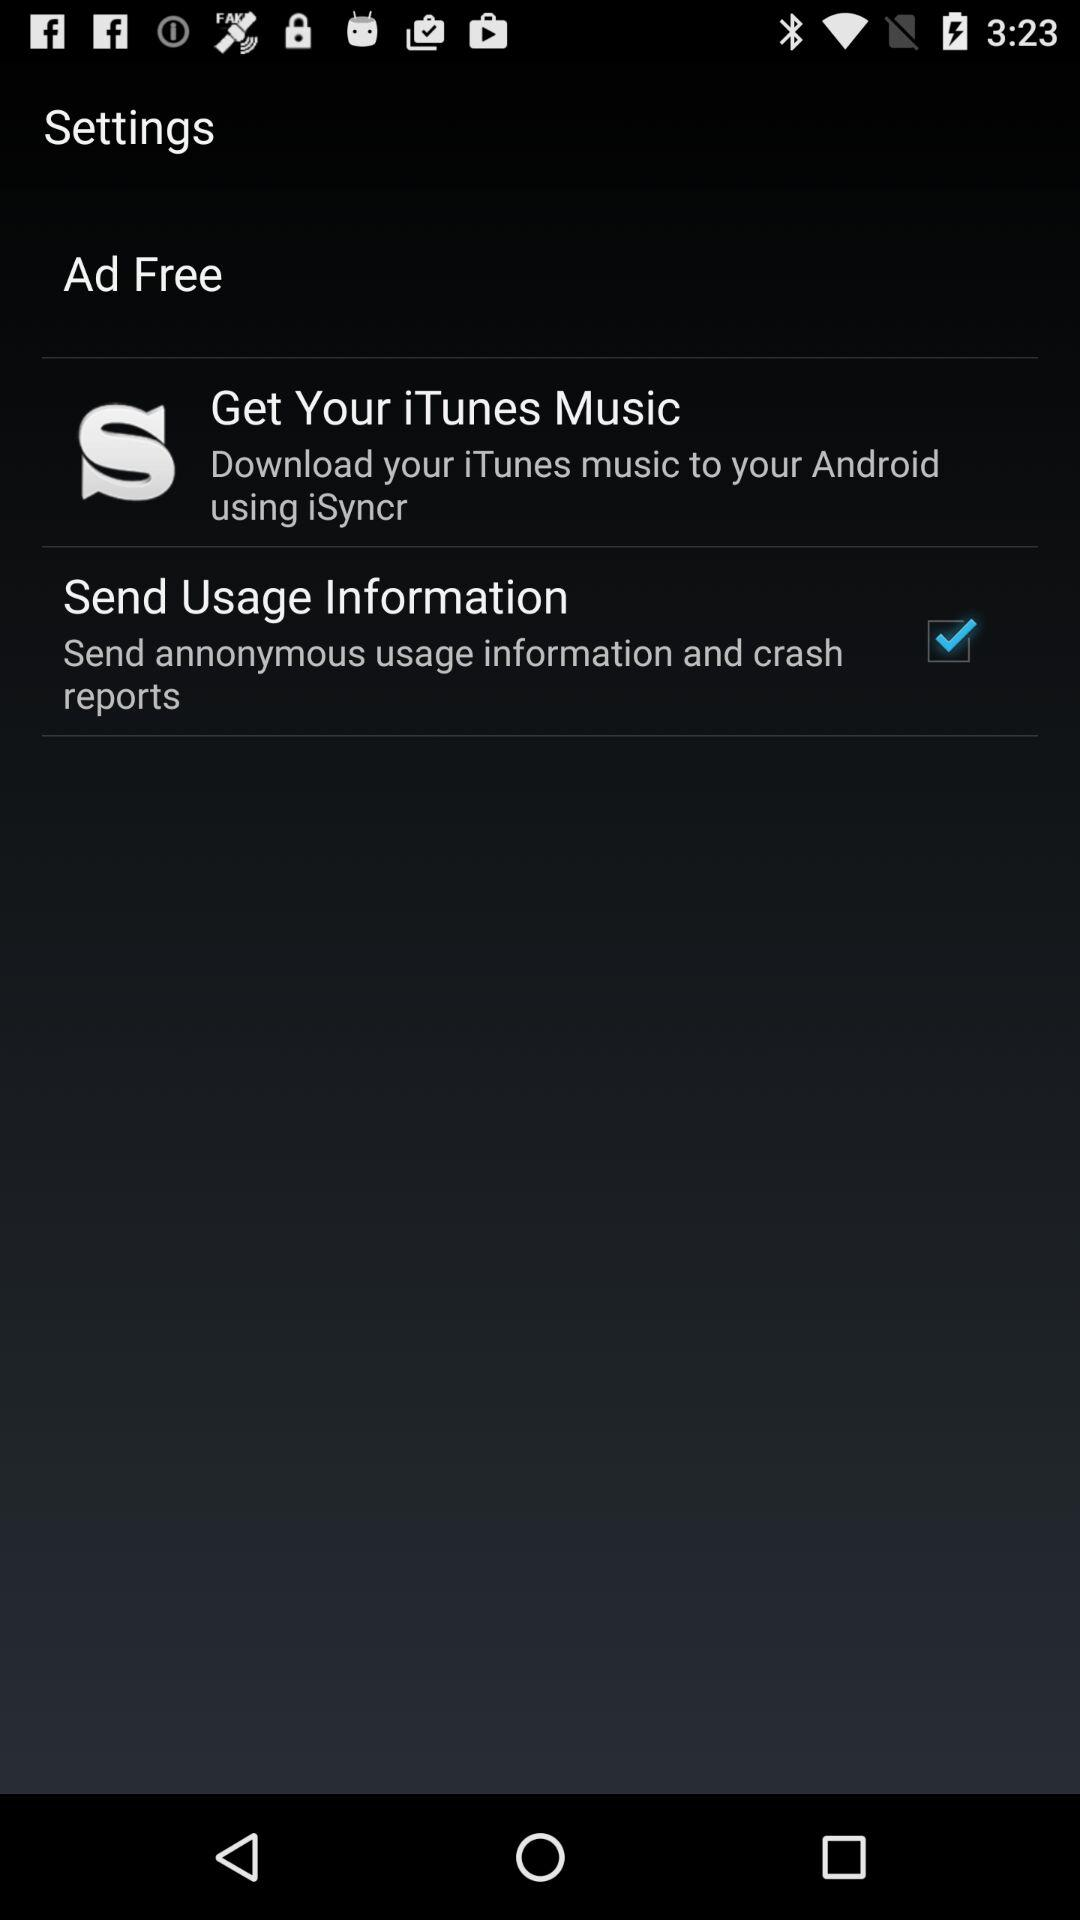How much music is downloaded?
When the provided information is insufficient, respond with <no answer>. <no answer> 